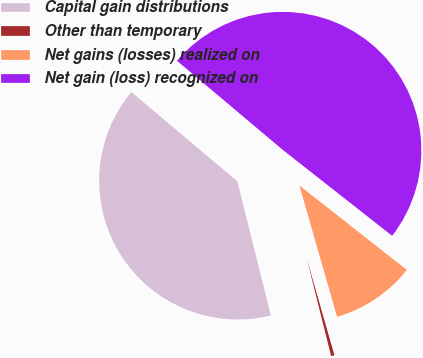<chart> <loc_0><loc_0><loc_500><loc_500><pie_chart><fcel>Capital gain distributions<fcel>Other than temporary<fcel>Net gains (losses) realized on<fcel>Net gain (loss) recognized on<nl><fcel>40.04%<fcel>0.54%<fcel>9.96%<fcel>49.46%<nl></chart> 